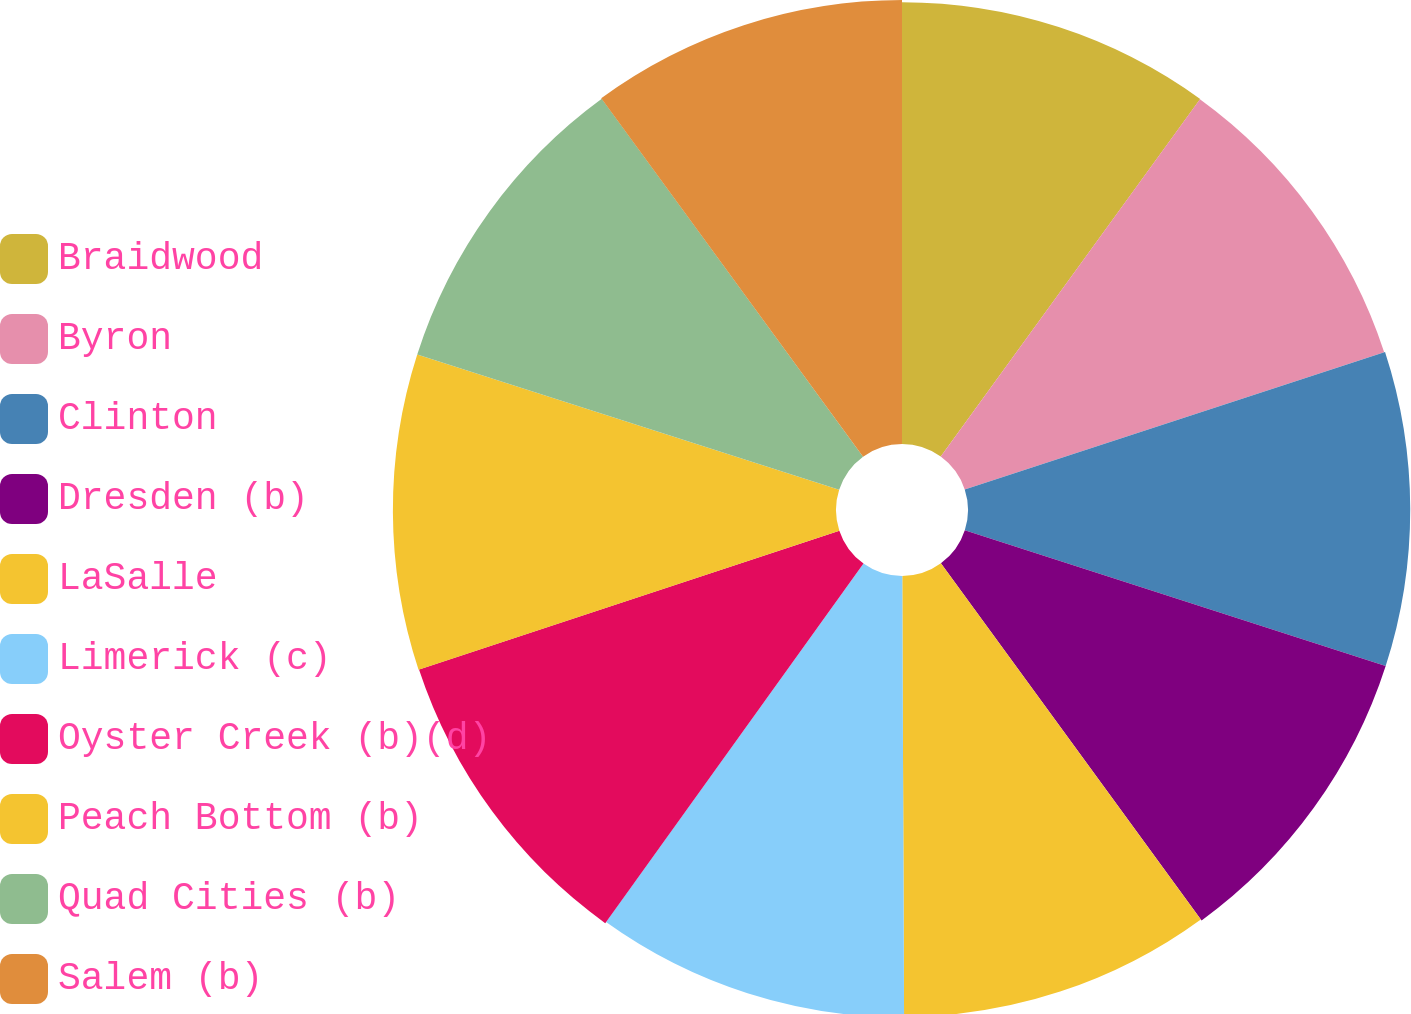Convert chart. <chart><loc_0><loc_0><loc_500><loc_500><pie_chart><fcel>Braidwood<fcel>Byron<fcel>Clinton<fcel>Dresden (b)<fcel>LaSalle<fcel>Limerick (c)<fcel>Oyster Creek (b)(d)<fcel>Peach Bottom (b)<fcel>Quad Cities (b)<fcel>Salem (b)<nl><fcel>9.99%<fcel>9.98%<fcel>10.0%<fcel>10.0%<fcel>9.97%<fcel>9.98%<fcel>10.01%<fcel>10.02%<fcel>10.02%<fcel>10.04%<nl></chart> 